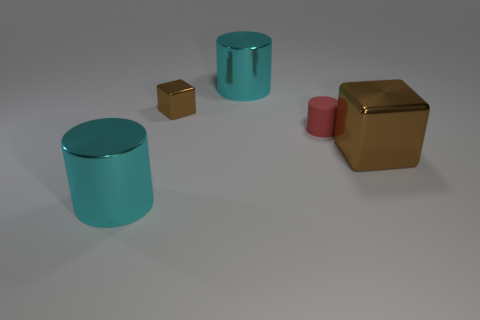What elements in the scene could suggest it's part of a matching set? The two golden cubes could imply a themed set, given their identical color and reflective surface, suggesting they are part of a collection. 